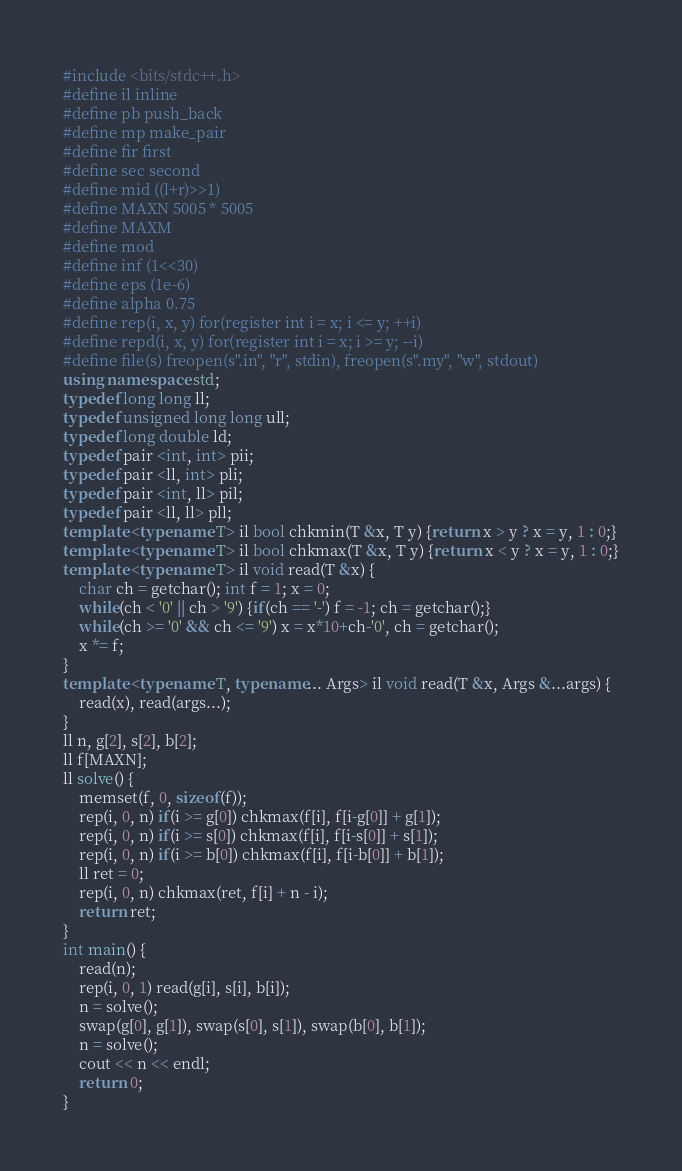Convert code to text. <code><loc_0><loc_0><loc_500><loc_500><_C++_>#include <bits/stdc++.h>
#define il inline
#define pb push_back
#define mp make_pair
#define fir first
#define sec second
#define mid ((l+r)>>1)
#define MAXN 5005 * 5005
#define MAXM 
#define mod
#define inf (1<<30)
#define eps (1e-6)
#define alpha 0.75
#define rep(i, x, y) for(register int i = x; i <= y; ++i)
#define repd(i, x, y) for(register int i = x; i >= y; --i)
#define file(s) freopen(s".in", "r", stdin), freopen(s".my", "w", stdout)
using namespace std;
typedef long long ll;
typedef unsigned long long ull;
typedef long double ld;
typedef pair <int, int> pii;
typedef pair <ll, int> pli;
typedef pair <int, ll> pil;
typedef pair <ll, ll> pll;
template <typename T> il bool chkmin(T &x, T y) {return x > y ? x = y, 1 : 0;}
template <typename T> il bool chkmax(T &x, T y) {return x < y ? x = y, 1 : 0;}
template <typename T> il void read(T &x) {
	char ch = getchar(); int f = 1; x = 0;
	while(ch < '0' || ch > '9') {if(ch == '-') f = -1; ch = getchar();}
	while(ch >= '0' && ch <= '9') x = x*10+ch-'0', ch = getchar();
	x *= f;
}
template <typename T, typename... Args> il void read(T &x, Args &...args) {
	read(x), read(args...);
}
ll n, g[2], s[2], b[2];
ll f[MAXN];
ll solve() {
	memset(f, 0, sizeof(f));
	rep(i, 0, n) if(i >= g[0]) chkmax(f[i], f[i-g[0]] + g[1]);
	rep(i, 0, n) if(i >= s[0]) chkmax(f[i], f[i-s[0]] + s[1]);
	rep(i, 0, n) if(i >= b[0]) chkmax(f[i], f[i-b[0]] + b[1]);
	ll ret = 0;
	rep(i, 0, n) chkmax(ret, f[i] + n - i);
	return ret;
}
int main() {
	read(n);
	rep(i, 0, 1) read(g[i], s[i], b[i]);
	n = solve();
	swap(g[0], g[1]), swap(s[0], s[1]), swap(b[0], b[1]);
	n = solve();
	cout << n << endl;
	return 0;
}</code> 